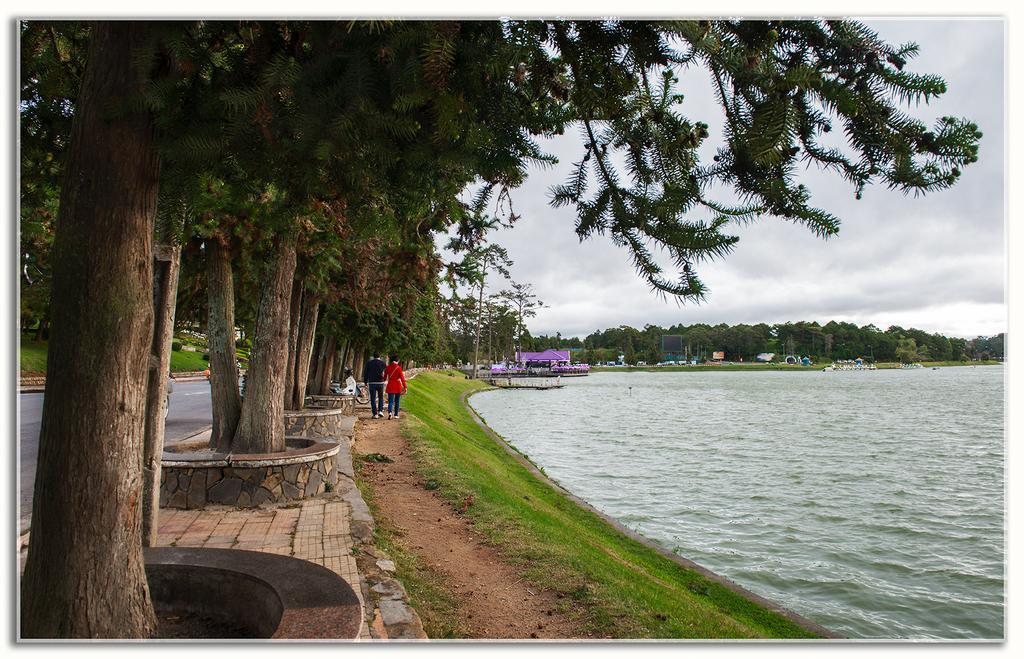Can you describe this image briefly? In this image, there are a few people, trees, plants, poles. We can see some water and the ground. We can also see some houses and grass. We can also see the sky with clouds. 